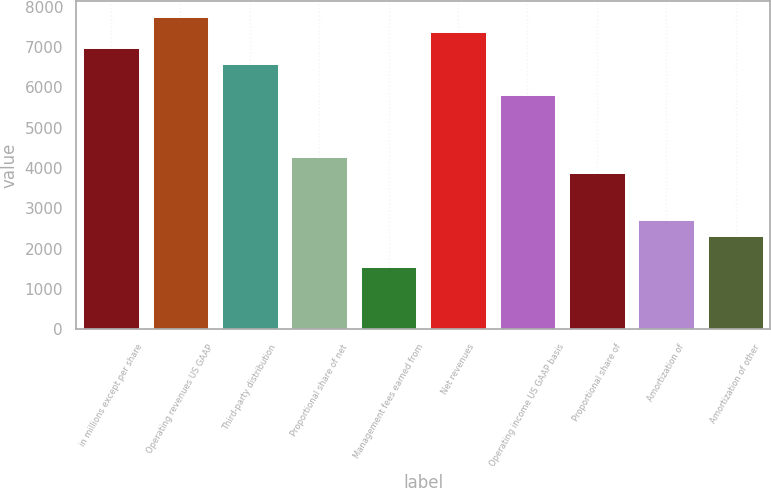Convert chart. <chart><loc_0><loc_0><loc_500><loc_500><bar_chart><fcel>in millions except per share<fcel>Operating revenues US GAAP<fcel>Third-party distribution<fcel>Proportional share of net<fcel>Management fees earned from<fcel>Net revenues<fcel>Operating income US GAAP basis<fcel>Proportional share of<fcel>Amortization of<fcel>Amortization of other<nl><fcel>6980.78<fcel>7756.24<fcel>6593.05<fcel>4266.67<fcel>1552.56<fcel>7368.51<fcel>5817.59<fcel>3878.94<fcel>2715.75<fcel>2328.02<nl></chart> 